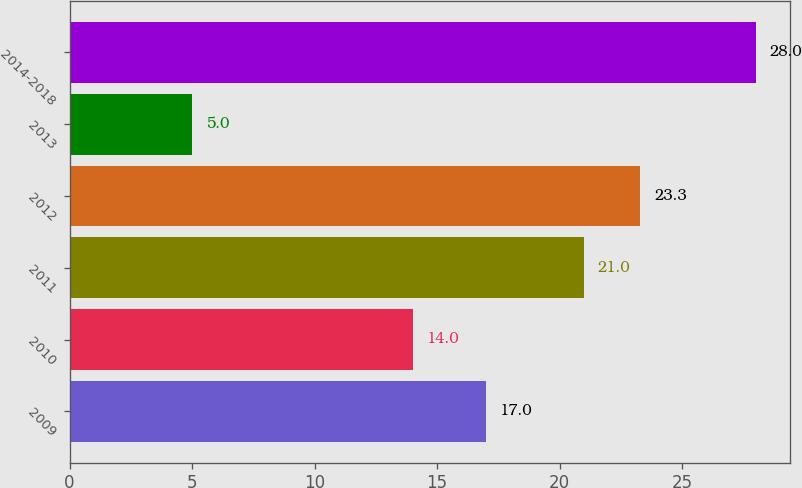Convert chart. <chart><loc_0><loc_0><loc_500><loc_500><bar_chart><fcel>2009<fcel>2010<fcel>2011<fcel>2012<fcel>2013<fcel>2014-2018<nl><fcel>17<fcel>14<fcel>21<fcel>23.3<fcel>5<fcel>28<nl></chart> 